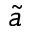Convert formula to latex. <formula><loc_0><loc_0><loc_500><loc_500>\tilde { a }</formula> 